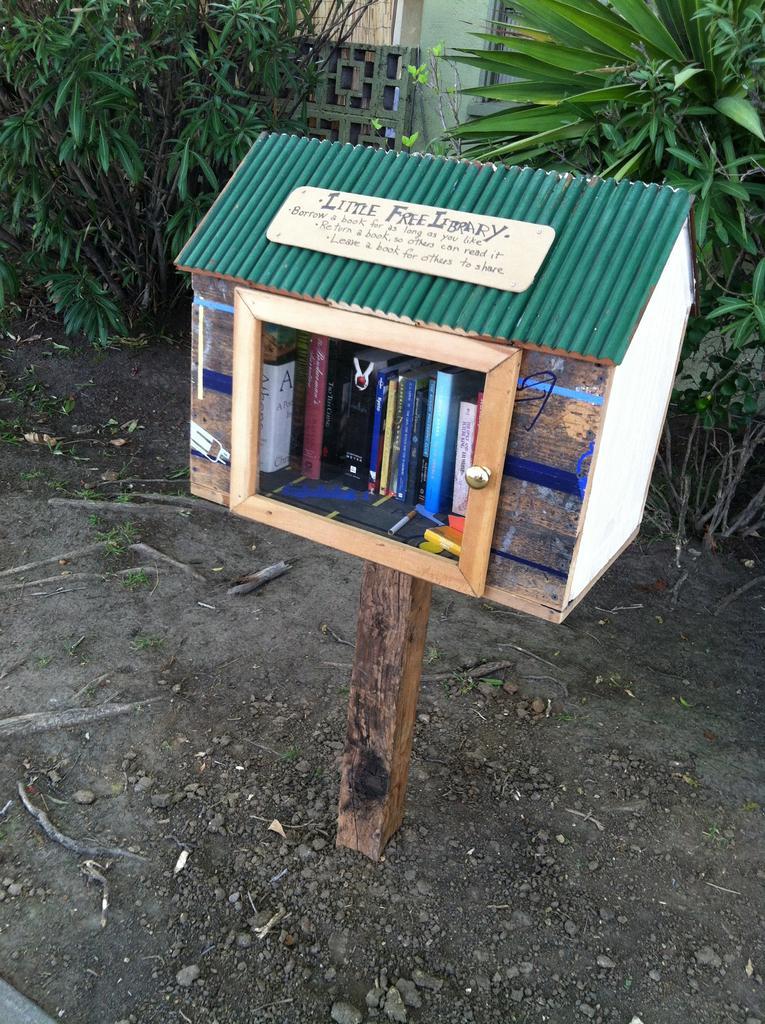In one or two sentences, can you explain what this image depicts? In this image we can see a toy house, inside the toy house we can see some books and on the toy house we can see a board with some text, there are some trees and stones on the ground, in the background, we can see a building. 